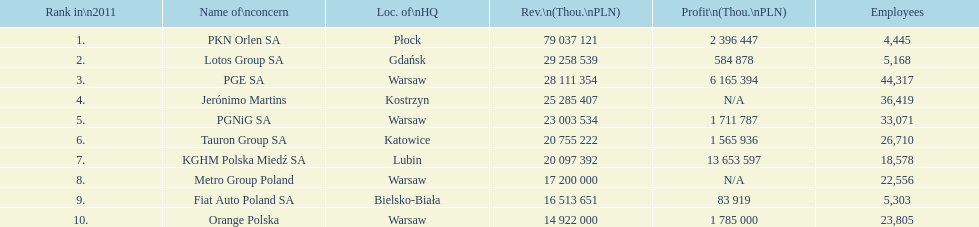Which organization had the highest number of workers? PGE SA. 